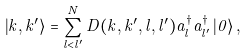Convert formula to latex. <formula><loc_0><loc_0><loc_500><loc_500>\left | k , k ^ { \prime } \right \rangle = \sum _ { l < l ^ { \prime } } ^ { N } D ( k , k ^ { \prime } , l , l ^ { \prime } ) a _ { l } ^ { \dagger } a _ { l ^ { \prime } } ^ { \dagger } \left | 0 \right \rangle ,</formula> 